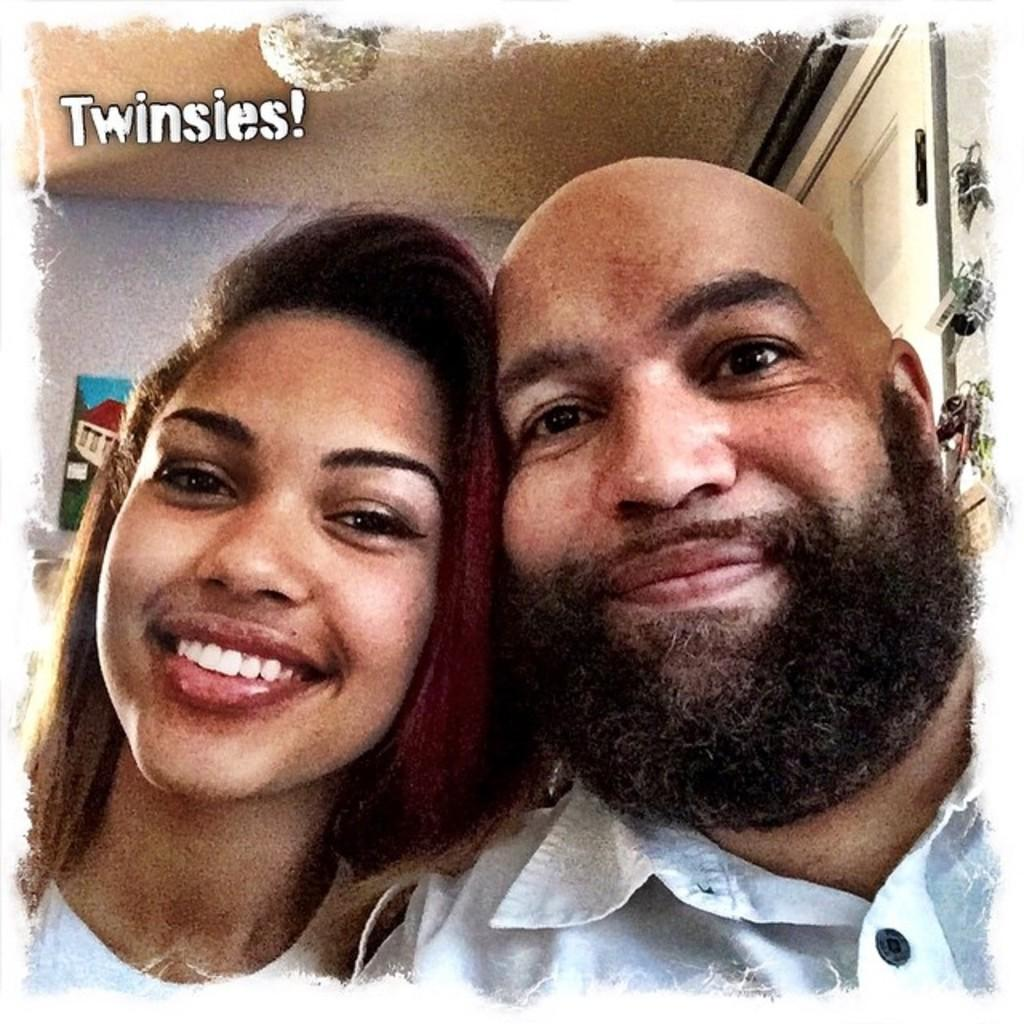Who are the people in the image? There is a woman and a man in the image. What expressions do the woman and the man have? Both the woman and the man are smiling in the image. What can be seen in the background of the image? There is a wall and a frame in the background of the image. What type of cave can be seen in the background of the image? There is no cave present in the image; it features a wall and a frame in the background. How does the bomb affect the mood of the people in the image? There is no bomb present in the image, so it cannot affect the mood of the people. 